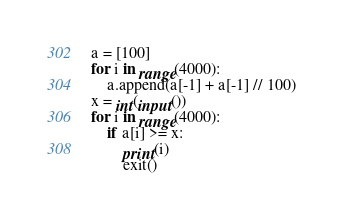<code> <loc_0><loc_0><loc_500><loc_500><_Python_>a = [100]
for i in range(4000):
    a.append(a[-1] + a[-1] // 100)
x = int(input())
for i in range(4000):
    if a[i] >= x:
        print(i)
        exit()</code> 